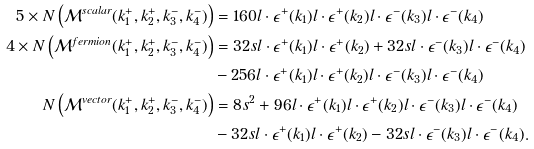Convert formula to latex. <formula><loc_0><loc_0><loc_500><loc_500>5 \times N \left ( \mathcal { M } ^ { s c a l a r } ( k _ { 1 } ^ { + } , k _ { 2 } ^ { + } , k _ { 3 } ^ { - } , k _ { 4 } ^ { - } ) \right ) & = 1 6 0 l \cdot \epsilon ^ { + } ( k _ { 1 } ) l \cdot \epsilon ^ { + } ( k _ { 2 } ) l \cdot \epsilon ^ { - } ( k _ { 3 } ) l \cdot \epsilon ^ { - } ( k _ { 4 } ) \\ 4 \times N \left ( \mathcal { M } ^ { f e r m i o n } ( k _ { 1 } ^ { + } , k _ { 2 } ^ { + } , k _ { 3 } ^ { - } , k _ { 4 } ^ { - } ) \right ) & = 3 2 s l \cdot \epsilon ^ { + } ( k _ { 1 } ) l \cdot \epsilon ^ { + } ( k _ { 2 } ) + 3 2 s l \cdot \epsilon ^ { - } ( k _ { 3 } ) l \cdot \epsilon ^ { - } ( k _ { 4 } ) \\ & - 2 5 6 l \cdot \epsilon ^ { + } ( k _ { 1 } ) l \cdot \epsilon ^ { + } ( k _ { 2 } ) l \cdot \epsilon ^ { - } ( k _ { 3 } ) l \cdot \epsilon ^ { - } ( k _ { 4 } ) \\ N \left ( \mathcal { M } ^ { v e c t o r } ( k _ { 1 } ^ { + } , k _ { 2 } ^ { + } , k _ { 3 } ^ { - } , k _ { 4 } ^ { - } ) \right ) & = 8 s ^ { 2 } + 9 6 l \cdot \epsilon ^ { + } ( k _ { 1 } ) l \cdot \epsilon ^ { + } ( k _ { 2 } ) l \cdot \epsilon ^ { - } ( k _ { 3 } ) l \cdot \epsilon ^ { - } ( k _ { 4 } ) \\ & - 3 2 s l \cdot \epsilon ^ { + } ( k _ { 1 } ) l \cdot \epsilon ^ { + } ( k _ { 2 } ) - 3 2 s l \cdot \epsilon ^ { - } ( k _ { 3 } ) l \cdot \epsilon ^ { - } ( k _ { 4 } ) .</formula> 